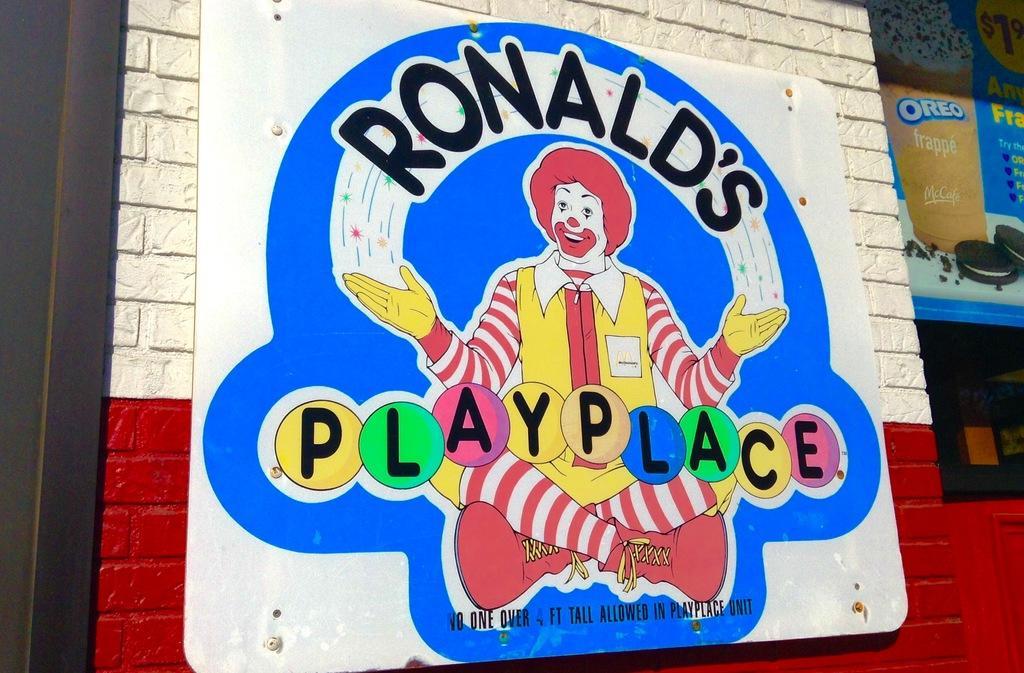Could you give a brief overview of what you see in this image? In this image in the center there is one board, on the board there is text and joker. And in the background there are buildings and some posters. 